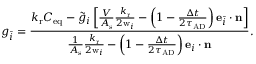<formula> <loc_0><loc_0><loc_500><loc_500>g _ { \bar { i } } = \frac { { k _ { r } C _ { e q } - \tilde { g } _ { i } \left [ { \frac { V } { A _ { s } } { \frac { k _ { r } } { 2 w _ { i } } } - \left ( 1 - { \frac { \Delta t } { 2 \tau _ { A D } } } \right ) e _ { \bar { i } } \cdot n } \right ] } } { { \frac { 1 } { A _ { s } } { \frac { k _ { r } } { 2 w _ { i } } } - \left ( 1 - { \frac { \Delta t } { 2 \tau _ { A D } } } \right ) e _ { i } \cdot n } } .</formula> 